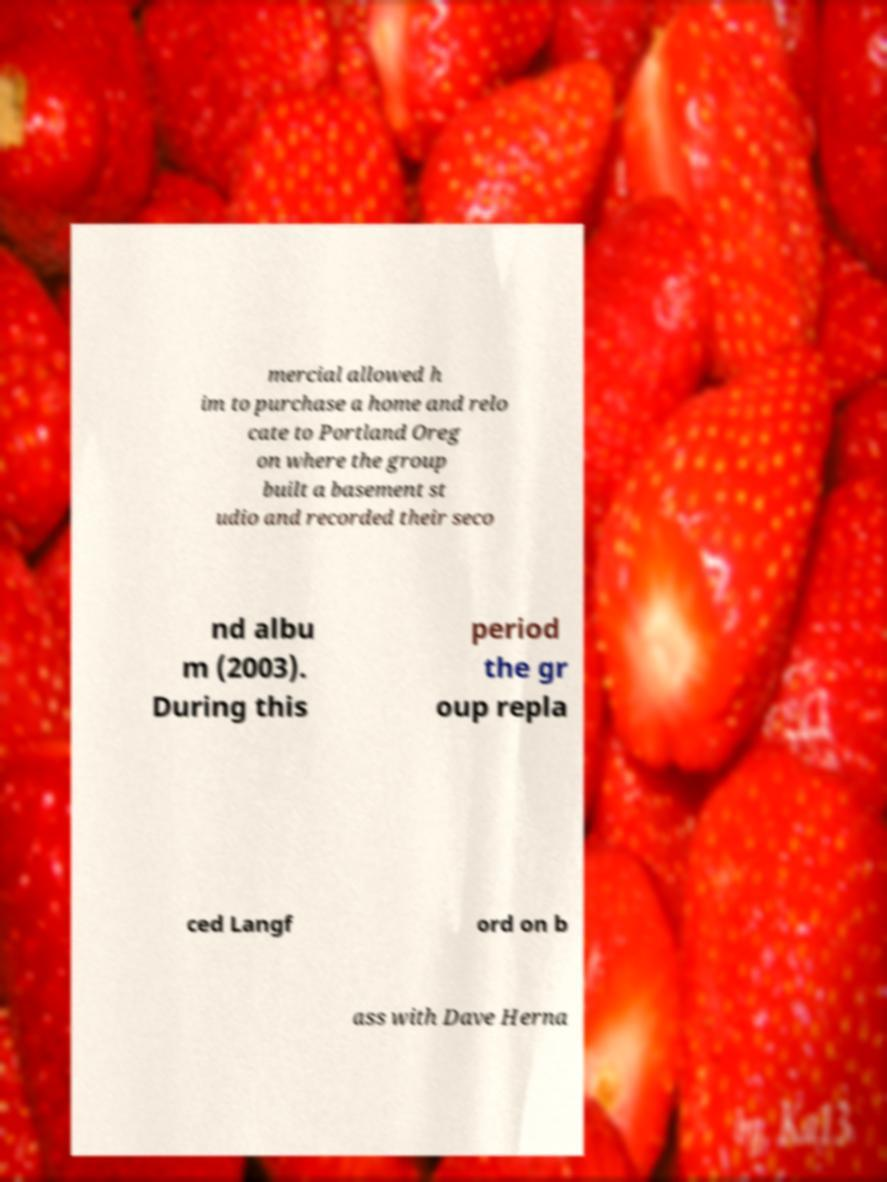Could you extract and type out the text from this image? mercial allowed h im to purchase a home and relo cate to Portland Oreg on where the group built a basement st udio and recorded their seco nd albu m (2003). During this period the gr oup repla ced Langf ord on b ass with Dave Herna 